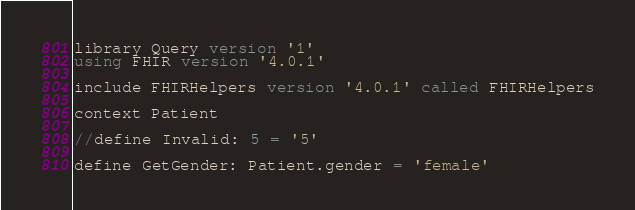Convert code to text. <code><loc_0><loc_0><loc_500><loc_500><_SQL_>library Query version '1'
using FHIR version '4.0.1'

include FHIRHelpers version '4.0.1' called FHIRHelpers

context Patient

//define Invalid: 5 = '5'

define GetGender: Patient.gender = 'female'
</code> 